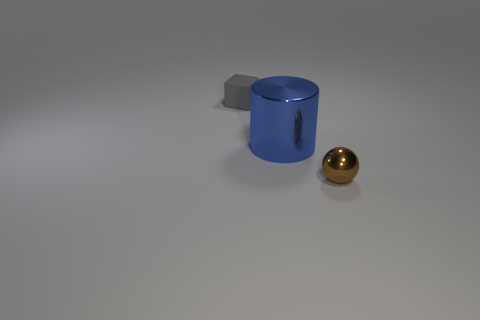There is a shiny thing that is left of the brown metal ball; how big is it?
Your response must be concise. Large. There is a shiny thing on the left side of the object in front of the big shiny thing; what size is it?
Your answer should be very brief. Large. Are there more gray matte things than big yellow rubber spheres?
Give a very brief answer. Yes. Is the number of small brown things that are in front of the tiny block greater than the number of big shiny things behind the cylinder?
Offer a very short reply. Yes. There is a object that is right of the tiny cube and to the left of the tiny brown metallic thing; what size is it?
Offer a terse response. Large. What number of gray cubes have the same size as the brown metallic ball?
Keep it short and to the point. 1. Is the number of rubber objects that are behind the tiny matte block less than the number of blue objects?
Ensure brevity in your answer.  Yes. Is there a tiny rubber cube of the same color as the large shiny cylinder?
Offer a very short reply. No. Do the small brown thing and the tiny object that is behind the large thing have the same shape?
Make the answer very short. No. Are there any small brown things that have the same material as the big thing?
Your answer should be compact. Yes. 